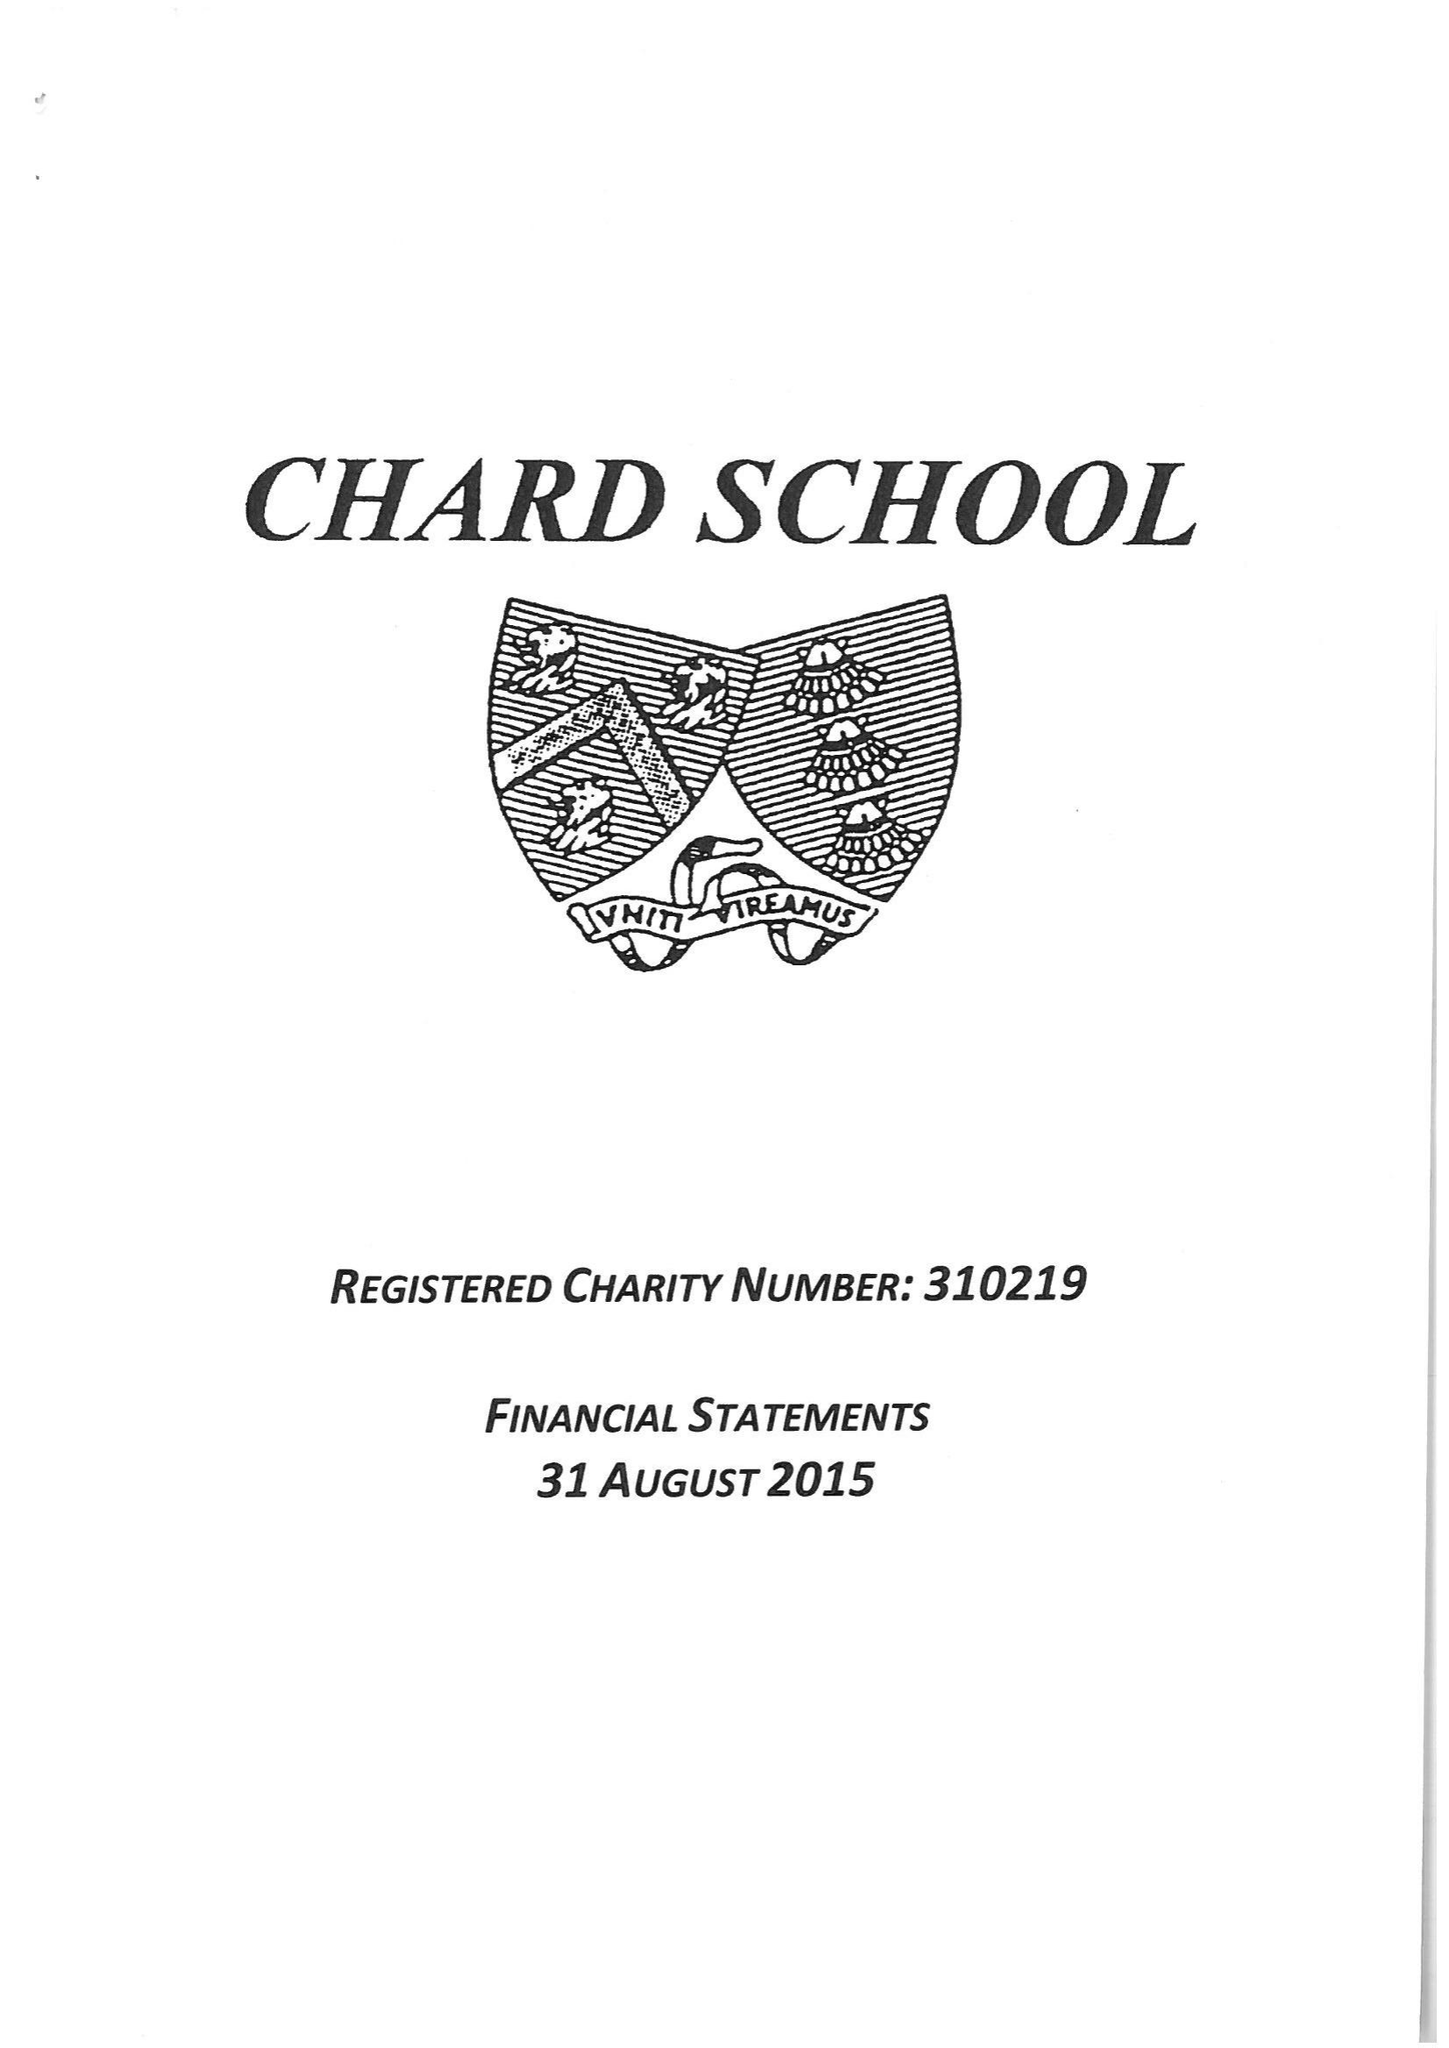What is the value for the charity_number?
Answer the question using a single word or phrase. 310219 